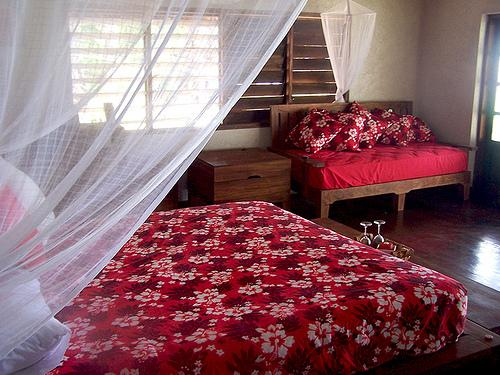Identify the color and pattern of the pillows on the couch. The pillows on the couch are red with white flowers. What type of furniture is most prominently featured in the image? The image prominently features a wooden couch with red cushions and pillows. Estimate the number of pillows in the image and describe their location. There are several pillows on the wooden couch, the bed, and the sofa in the corner of the room. What is hanging over the bed, and what color is it? A white shear sheet or net is hanging over the bed. Point out the objects or elements that contribute to a cozy atmosphere in this image. Couch with pillows, wooden table, windows with blinds, and light coming in from the door contribute to a cozy atmosphere. What kind of flooring does the room have, and describe its color. The room has hard wood flooring with a dark brown color. Mention the type of sheet that is covering the bed. There is a mattress with a red and white sheet and a floral print bedspread on it. Briefly describe the location and arrangement of wine glasses in the image. There are two wine glasses upside down in a basket at the foot of the bed. How many windows are in the room, and what kind of blinds cover them? There are windows with wooden, brown blinds in the room. Is there a green couch with blue cushions in the image? There is no mention of a green couch or blue cushions in the image. All the couches mentioned have either brown or red cushions. Are there any yellow pillows with black stripes on the bed? All the pillows mentioned in the image are either red with white flowers or have a floral print. There are no yellow pillows with black stripes. Is there a ceiling fan in the room? No, it's not mentioned in the image. Can you find a round glass table in the room? All the tables described in the image are wooden and brown. There is no mention of a glass table or a round table. Is there a door in the room with blue curtains? There is no mention of a door with curtains in the image, only windows. Additionally, there are no blue curtains described, only white ones. Can you see a metal dresser next to the couch? The dresser mentioned in the image is wooden, not metal. There is no mention of a metal dresser in the image. 